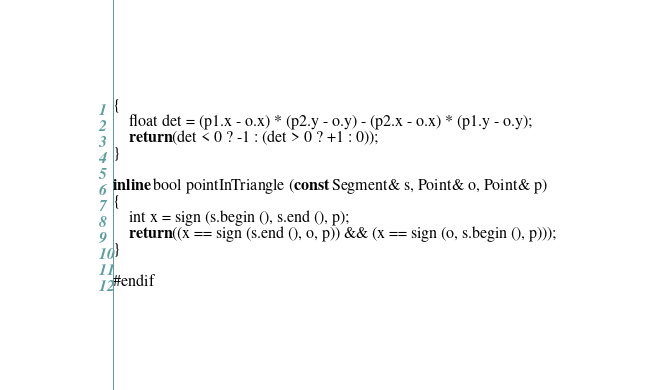<code> <loc_0><loc_0><loc_500><loc_500><_C_>{
	float det = (p1.x - o.x) * (p2.y - o.y) - (p2.x - o.x) * (p1.y - o.y);
	return (det < 0 ? -1 : (det > 0 ? +1 : 0));
}

inline bool pointInTriangle (const Segment& s, Point& o, Point& p)
{
	int x = sign (s.begin (), s.end (), p);
	return ((x == sign (s.end (), o, p)) && (x == sign (o, s.begin (), p)));
}

#endif
</code> 